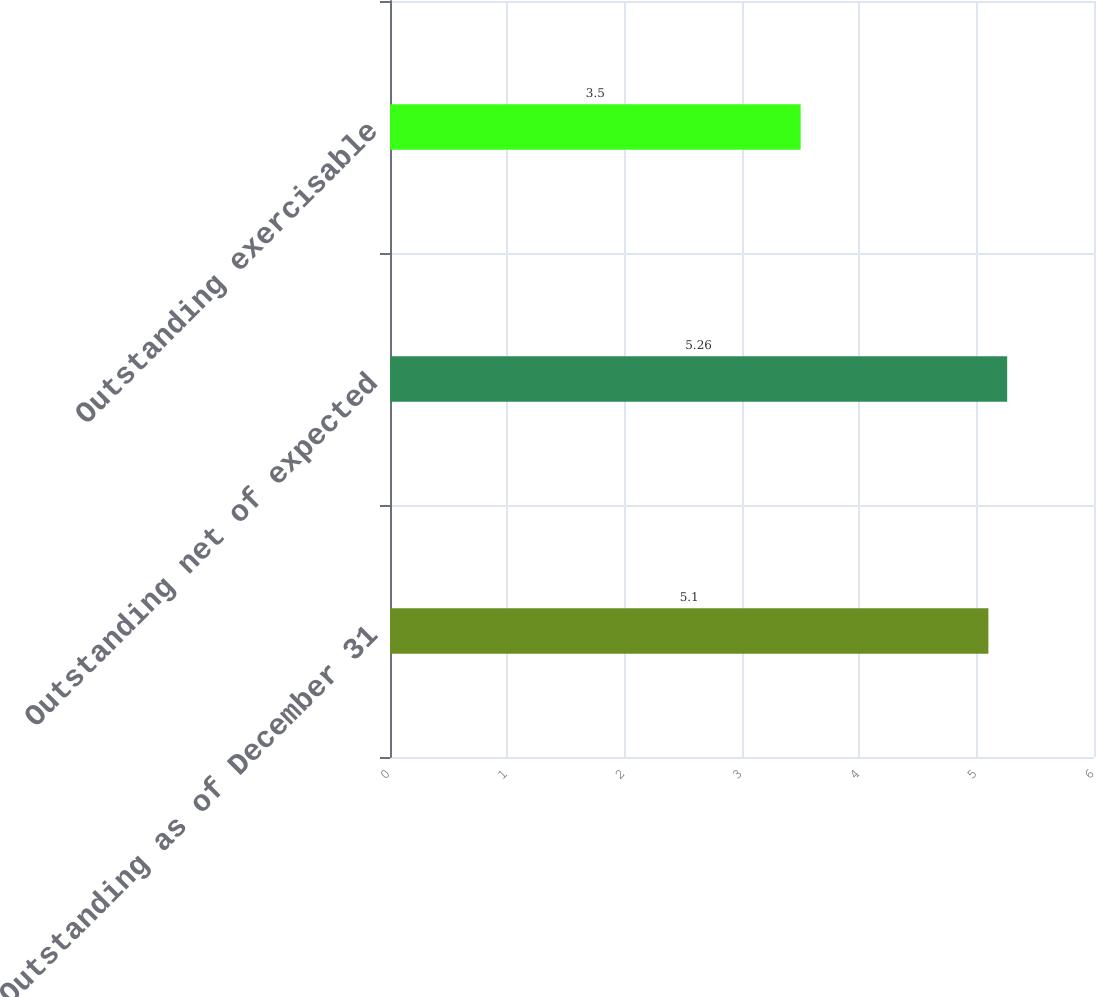Convert chart to OTSL. <chart><loc_0><loc_0><loc_500><loc_500><bar_chart><fcel>Outstanding as of December 31<fcel>Outstanding net of expected<fcel>Outstanding exercisable<nl><fcel>5.1<fcel>5.26<fcel>3.5<nl></chart> 